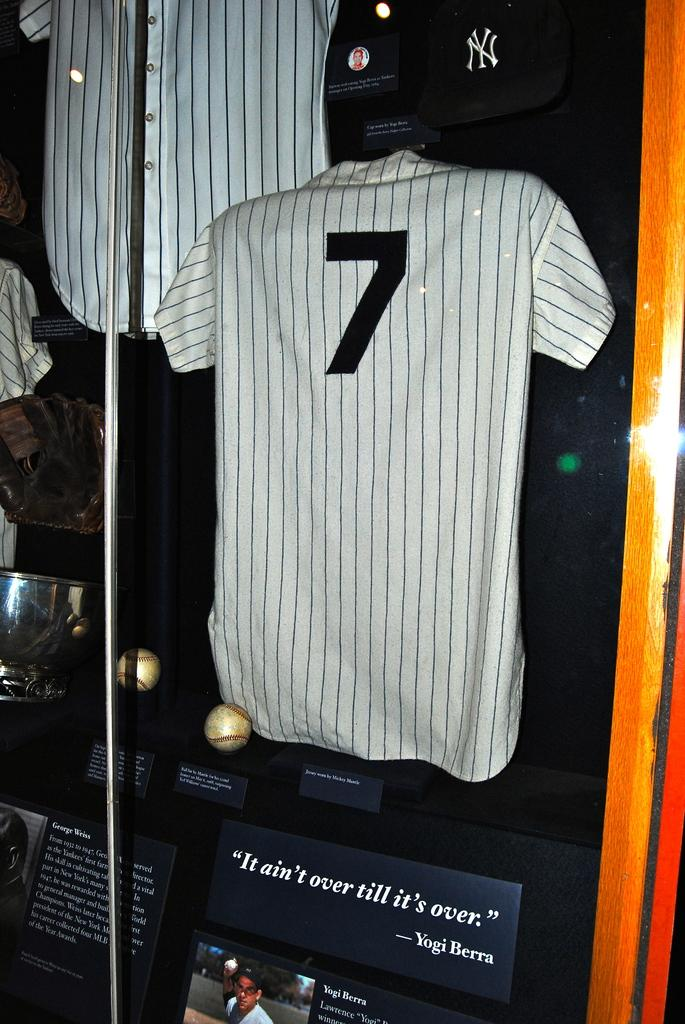Provide a one-sentence caption for the provided image. A display of Yogi Berras uniform and a few collectibles including a famous quote. 